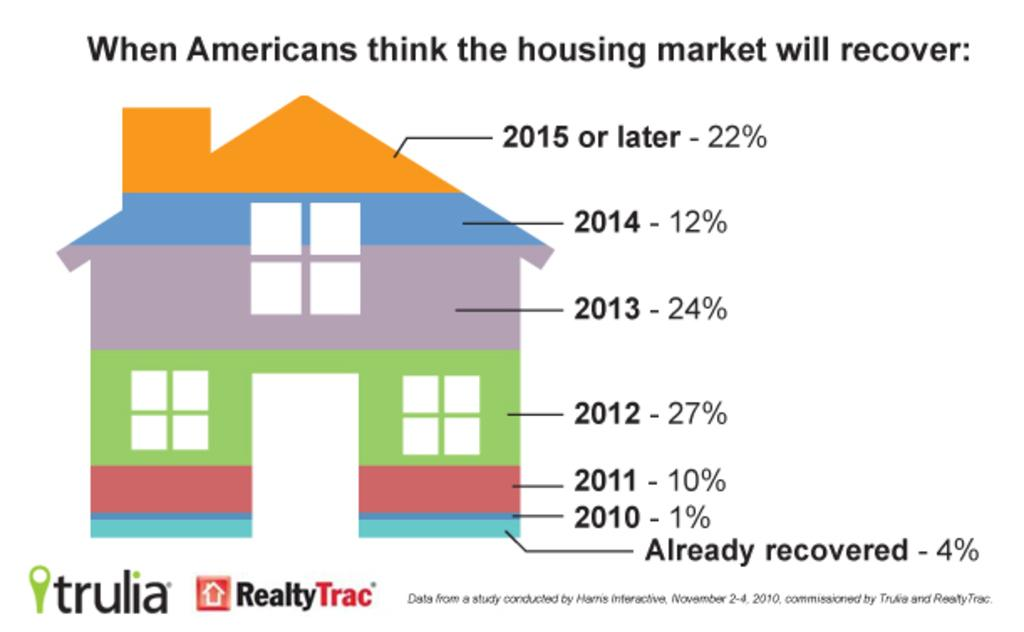What is depicted in the image? There is a drawing of a house in the image. Can you describe the colors used in the drawing? The drawing of the house has different colors. Does the drawing of the house show the brother of the artist? There is no information about the artist or their siblings in the image, so it cannot be determined if the drawing shows the brother of the artist. 